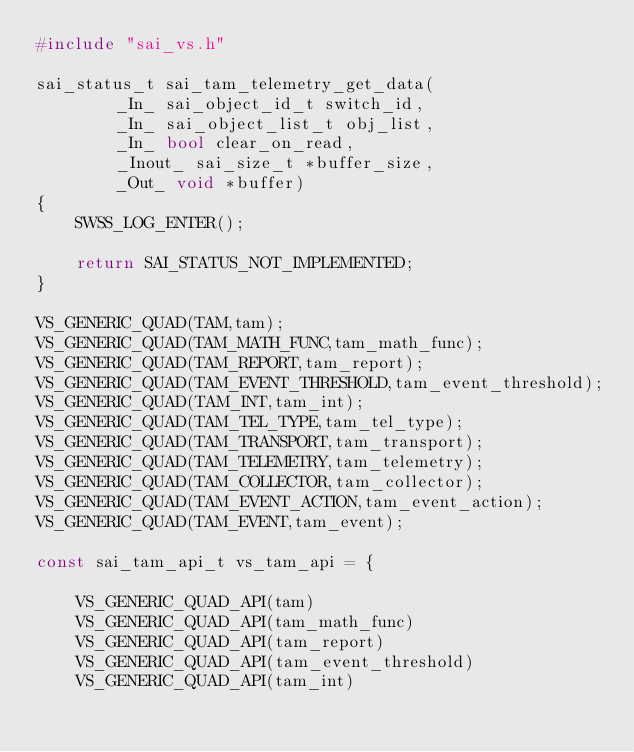<code> <loc_0><loc_0><loc_500><loc_500><_C++_>#include "sai_vs.h"

sai_status_t sai_tam_telemetry_get_data(
        _In_ sai_object_id_t switch_id,
        _In_ sai_object_list_t obj_list,
        _In_ bool clear_on_read,
        _Inout_ sai_size_t *buffer_size,
        _Out_ void *buffer)
{
    SWSS_LOG_ENTER();

    return SAI_STATUS_NOT_IMPLEMENTED;
}

VS_GENERIC_QUAD(TAM,tam);
VS_GENERIC_QUAD(TAM_MATH_FUNC,tam_math_func);
VS_GENERIC_QUAD(TAM_REPORT,tam_report);
VS_GENERIC_QUAD(TAM_EVENT_THRESHOLD,tam_event_threshold);
VS_GENERIC_QUAD(TAM_INT,tam_int);
VS_GENERIC_QUAD(TAM_TEL_TYPE,tam_tel_type);
VS_GENERIC_QUAD(TAM_TRANSPORT,tam_transport);
VS_GENERIC_QUAD(TAM_TELEMETRY,tam_telemetry);
VS_GENERIC_QUAD(TAM_COLLECTOR,tam_collector);
VS_GENERIC_QUAD(TAM_EVENT_ACTION,tam_event_action);
VS_GENERIC_QUAD(TAM_EVENT,tam_event);

const sai_tam_api_t vs_tam_api = {

    VS_GENERIC_QUAD_API(tam)
    VS_GENERIC_QUAD_API(tam_math_func)
    VS_GENERIC_QUAD_API(tam_report)
    VS_GENERIC_QUAD_API(tam_event_threshold)
    VS_GENERIC_QUAD_API(tam_int)</code> 